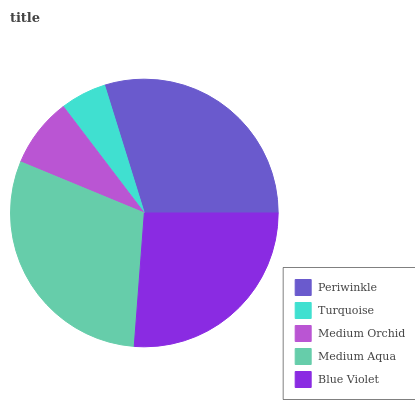Is Turquoise the minimum?
Answer yes or no. Yes. Is Medium Aqua the maximum?
Answer yes or no. Yes. Is Medium Orchid the minimum?
Answer yes or no. No. Is Medium Orchid the maximum?
Answer yes or no. No. Is Medium Orchid greater than Turquoise?
Answer yes or no. Yes. Is Turquoise less than Medium Orchid?
Answer yes or no. Yes. Is Turquoise greater than Medium Orchid?
Answer yes or no. No. Is Medium Orchid less than Turquoise?
Answer yes or no. No. Is Blue Violet the high median?
Answer yes or no. Yes. Is Blue Violet the low median?
Answer yes or no. Yes. Is Periwinkle the high median?
Answer yes or no. No. Is Medium Aqua the low median?
Answer yes or no. No. 